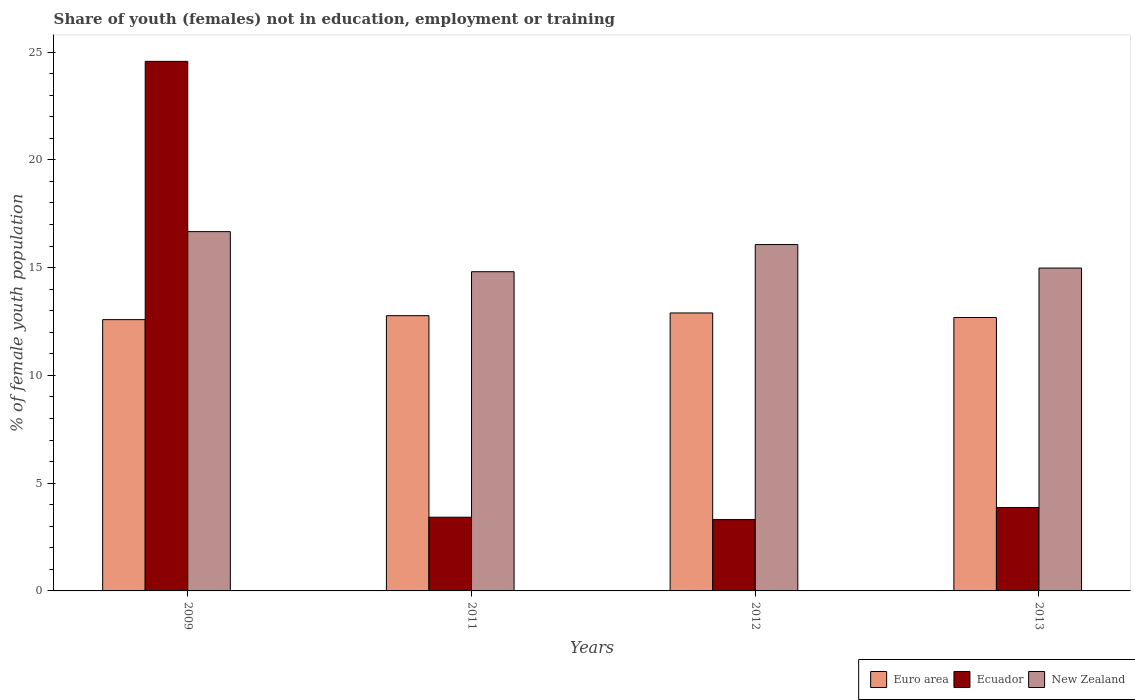How many different coloured bars are there?
Keep it short and to the point. 3. How many groups of bars are there?
Give a very brief answer. 4. Are the number of bars per tick equal to the number of legend labels?
Your response must be concise. Yes. Are the number of bars on each tick of the X-axis equal?
Your answer should be compact. Yes. How many bars are there on the 2nd tick from the left?
Offer a very short reply. 3. How many bars are there on the 3rd tick from the right?
Your answer should be very brief. 3. In how many cases, is the number of bars for a given year not equal to the number of legend labels?
Give a very brief answer. 0. What is the percentage of unemployed female population in in Ecuador in 2011?
Keep it short and to the point. 3.42. Across all years, what is the maximum percentage of unemployed female population in in Euro area?
Provide a succinct answer. 12.9. Across all years, what is the minimum percentage of unemployed female population in in Euro area?
Keep it short and to the point. 12.59. In which year was the percentage of unemployed female population in in Euro area maximum?
Make the answer very short. 2012. In which year was the percentage of unemployed female population in in New Zealand minimum?
Offer a very short reply. 2011. What is the total percentage of unemployed female population in in Euro area in the graph?
Your answer should be very brief. 50.94. What is the difference between the percentage of unemployed female population in in New Zealand in 2009 and that in 2013?
Your answer should be compact. 1.69. What is the difference between the percentage of unemployed female population in in Euro area in 2009 and the percentage of unemployed female population in in New Zealand in 2013?
Provide a short and direct response. -2.39. What is the average percentage of unemployed female population in in Ecuador per year?
Offer a very short reply. 8.79. In the year 2013, what is the difference between the percentage of unemployed female population in in New Zealand and percentage of unemployed female population in in Euro area?
Ensure brevity in your answer.  2.29. What is the ratio of the percentage of unemployed female population in in Euro area in 2009 to that in 2013?
Ensure brevity in your answer.  0.99. Is the difference between the percentage of unemployed female population in in New Zealand in 2009 and 2012 greater than the difference between the percentage of unemployed female population in in Euro area in 2009 and 2012?
Provide a short and direct response. Yes. What is the difference between the highest and the second highest percentage of unemployed female population in in New Zealand?
Keep it short and to the point. 0.6. What is the difference between the highest and the lowest percentage of unemployed female population in in Ecuador?
Keep it short and to the point. 21.26. What does the 2nd bar from the right in 2013 represents?
Provide a short and direct response. Ecuador. How many bars are there?
Offer a terse response. 12. How many years are there in the graph?
Make the answer very short. 4. Does the graph contain grids?
Ensure brevity in your answer.  No. Where does the legend appear in the graph?
Keep it short and to the point. Bottom right. How many legend labels are there?
Make the answer very short. 3. What is the title of the graph?
Ensure brevity in your answer.  Share of youth (females) not in education, employment or training. What is the label or title of the Y-axis?
Ensure brevity in your answer.  % of female youth population. What is the % of female youth population of Euro area in 2009?
Offer a terse response. 12.59. What is the % of female youth population in Ecuador in 2009?
Keep it short and to the point. 24.57. What is the % of female youth population in New Zealand in 2009?
Your answer should be compact. 16.67. What is the % of female youth population in Euro area in 2011?
Your response must be concise. 12.77. What is the % of female youth population of Ecuador in 2011?
Your answer should be very brief. 3.42. What is the % of female youth population in New Zealand in 2011?
Offer a terse response. 14.81. What is the % of female youth population of Euro area in 2012?
Keep it short and to the point. 12.9. What is the % of female youth population of Ecuador in 2012?
Keep it short and to the point. 3.31. What is the % of female youth population in New Zealand in 2012?
Provide a succinct answer. 16.07. What is the % of female youth population of Euro area in 2013?
Your response must be concise. 12.69. What is the % of female youth population in Ecuador in 2013?
Your response must be concise. 3.87. What is the % of female youth population of New Zealand in 2013?
Keep it short and to the point. 14.98. Across all years, what is the maximum % of female youth population of Euro area?
Provide a short and direct response. 12.9. Across all years, what is the maximum % of female youth population of Ecuador?
Offer a very short reply. 24.57. Across all years, what is the maximum % of female youth population of New Zealand?
Provide a short and direct response. 16.67. Across all years, what is the minimum % of female youth population in Euro area?
Offer a terse response. 12.59. Across all years, what is the minimum % of female youth population in Ecuador?
Provide a short and direct response. 3.31. Across all years, what is the minimum % of female youth population in New Zealand?
Ensure brevity in your answer.  14.81. What is the total % of female youth population in Euro area in the graph?
Your answer should be compact. 50.94. What is the total % of female youth population in Ecuador in the graph?
Give a very brief answer. 35.17. What is the total % of female youth population of New Zealand in the graph?
Offer a terse response. 62.53. What is the difference between the % of female youth population of Euro area in 2009 and that in 2011?
Provide a succinct answer. -0.18. What is the difference between the % of female youth population in Ecuador in 2009 and that in 2011?
Your answer should be compact. 21.15. What is the difference between the % of female youth population in New Zealand in 2009 and that in 2011?
Keep it short and to the point. 1.86. What is the difference between the % of female youth population of Euro area in 2009 and that in 2012?
Provide a succinct answer. -0.31. What is the difference between the % of female youth population in Ecuador in 2009 and that in 2012?
Offer a terse response. 21.26. What is the difference between the % of female youth population in New Zealand in 2009 and that in 2012?
Your response must be concise. 0.6. What is the difference between the % of female youth population in Euro area in 2009 and that in 2013?
Your answer should be very brief. -0.1. What is the difference between the % of female youth population of Ecuador in 2009 and that in 2013?
Offer a terse response. 20.7. What is the difference between the % of female youth population in New Zealand in 2009 and that in 2013?
Provide a succinct answer. 1.69. What is the difference between the % of female youth population of Euro area in 2011 and that in 2012?
Your answer should be very brief. -0.13. What is the difference between the % of female youth population of Ecuador in 2011 and that in 2012?
Provide a short and direct response. 0.11. What is the difference between the % of female youth population in New Zealand in 2011 and that in 2012?
Provide a succinct answer. -1.26. What is the difference between the % of female youth population in Euro area in 2011 and that in 2013?
Your response must be concise. 0.08. What is the difference between the % of female youth population in Ecuador in 2011 and that in 2013?
Ensure brevity in your answer.  -0.45. What is the difference between the % of female youth population of New Zealand in 2011 and that in 2013?
Provide a succinct answer. -0.17. What is the difference between the % of female youth population in Euro area in 2012 and that in 2013?
Provide a succinct answer. 0.21. What is the difference between the % of female youth population of Ecuador in 2012 and that in 2013?
Offer a terse response. -0.56. What is the difference between the % of female youth population of New Zealand in 2012 and that in 2013?
Keep it short and to the point. 1.09. What is the difference between the % of female youth population of Euro area in 2009 and the % of female youth population of Ecuador in 2011?
Ensure brevity in your answer.  9.17. What is the difference between the % of female youth population of Euro area in 2009 and the % of female youth population of New Zealand in 2011?
Keep it short and to the point. -2.22. What is the difference between the % of female youth population of Ecuador in 2009 and the % of female youth population of New Zealand in 2011?
Your answer should be very brief. 9.76. What is the difference between the % of female youth population of Euro area in 2009 and the % of female youth population of Ecuador in 2012?
Provide a succinct answer. 9.28. What is the difference between the % of female youth population of Euro area in 2009 and the % of female youth population of New Zealand in 2012?
Your response must be concise. -3.48. What is the difference between the % of female youth population in Euro area in 2009 and the % of female youth population in Ecuador in 2013?
Keep it short and to the point. 8.72. What is the difference between the % of female youth population in Euro area in 2009 and the % of female youth population in New Zealand in 2013?
Provide a short and direct response. -2.39. What is the difference between the % of female youth population in Ecuador in 2009 and the % of female youth population in New Zealand in 2013?
Make the answer very short. 9.59. What is the difference between the % of female youth population of Euro area in 2011 and the % of female youth population of Ecuador in 2012?
Offer a terse response. 9.46. What is the difference between the % of female youth population in Euro area in 2011 and the % of female youth population in New Zealand in 2012?
Offer a terse response. -3.3. What is the difference between the % of female youth population of Ecuador in 2011 and the % of female youth population of New Zealand in 2012?
Offer a very short reply. -12.65. What is the difference between the % of female youth population of Euro area in 2011 and the % of female youth population of Ecuador in 2013?
Your answer should be compact. 8.9. What is the difference between the % of female youth population in Euro area in 2011 and the % of female youth population in New Zealand in 2013?
Provide a short and direct response. -2.21. What is the difference between the % of female youth population in Ecuador in 2011 and the % of female youth population in New Zealand in 2013?
Offer a terse response. -11.56. What is the difference between the % of female youth population of Euro area in 2012 and the % of female youth population of Ecuador in 2013?
Offer a terse response. 9.03. What is the difference between the % of female youth population of Euro area in 2012 and the % of female youth population of New Zealand in 2013?
Your answer should be compact. -2.08. What is the difference between the % of female youth population of Ecuador in 2012 and the % of female youth population of New Zealand in 2013?
Your response must be concise. -11.67. What is the average % of female youth population of Euro area per year?
Ensure brevity in your answer.  12.73. What is the average % of female youth population of Ecuador per year?
Provide a succinct answer. 8.79. What is the average % of female youth population in New Zealand per year?
Offer a very short reply. 15.63. In the year 2009, what is the difference between the % of female youth population in Euro area and % of female youth population in Ecuador?
Offer a very short reply. -11.98. In the year 2009, what is the difference between the % of female youth population in Euro area and % of female youth population in New Zealand?
Ensure brevity in your answer.  -4.08. In the year 2011, what is the difference between the % of female youth population of Euro area and % of female youth population of Ecuador?
Your answer should be very brief. 9.35. In the year 2011, what is the difference between the % of female youth population of Euro area and % of female youth population of New Zealand?
Your answer should be compact. -2.04. In the year 2011, what is the difference between the % of female youth population of Ecuador and % of female youth population of New Zealand?
Your answer should be very brief. -11.39. In the year 2012, what is the difference between the % of female youth population of Euro area and % of female youth population of Ecuador?
Give a very brief answer. 9.59. In the year 2012, what is the difference between the % of female youth population in Euro area and % of female youth population in New Zealand?
Give a very brief answer. -3.17. In the year 2012, what is the difference between the % of female youth population of Ecuador and % of female youth population of New Zealand?
Give a very brief answer. -12.76. In the year 2013, what is the difference between the % of female youth population in Euro area and % of female youth population in Ecuador?
Ensure brevity in your answer.  8.82. In the year 2013, what is the difference between the % of female youth population of Euro area and % of female youth population of New Zealand?
Offer a terse response. -2.29. In the year 2013, what is the difference between the % of female youth population in Ecuador and % of female youth population in New Zealand?
Give a very brief answer. -11.11. What is the ratio of the % of female youth population in Euro area in 2009 to that in 2011?
Ensure brevity in your answer.  0.99. What is the ratio of the % of female youth population in Ecuador in 2009 to that in 2011?
Your response must be concise. 7.18. What is the ratio of the % of female youth population in New Zealand in 2009 to that in 2011?
Provide a short and direct response. 1.13. What is the ratio of the % of female youth population of Ecuador in 2009 to that in 2012?
Offer a terse response. 7.42. What is the ratio of the % of female youth population in New Zealand in 2009 to that in 2012?
Provide a succinct answer. 1.04. What is the ratio of the % of female youth population in Ecuador in 2009 to that in 2013?
Give a very brief answer. 6.35. What is the ratio of the % of female youth population of New Zealand in 2009 to that in 2013?
Provide a short and direct response. 1.11. What is the ratio of the % of female youth population in Euro area in 2011 to that in 2012?
Provide a short and direct response. 0.99. What is the ratio of the % of female youth population in Ecuador in 2011 to that in 2012?
Offer a terse response. 1.03. What is the ratio of the % of female youth population of New Zealand in 2011 to that in 2012?
Keep it short and to the point. 0.92. What is the ratio of the % of female youth population of Euro area in 2011 to that in 2013?
Ensure brevity in your answer.  1.01. What is the ratio of the % of female youth population in Ecuador in 2011 to that in 2013?
Your answer should be very brief. 0.88. What is the ratio of the % of female youth population of New Zealand in 2011 to that in 2013?
Keep it short and to the point. 0.99. What is the ratio of the % of female youth population in Euro area in 2012 to that in 2013?
Offer a terse response. 1.02. What is the ratio of the % of female youth population of Ecuador in 2012 to that in 2013?
Ensure brevity in your answer.  0.86. What is the ratio of the % of female youth population in New Zealand in 2012 to that in 2013?
Provide a short and direct response. 1.07. What is the difference between the highest and the second highest % of female youth population of Euro area?
Offer a very short reply. 0.13. What is the difference between the highest and the second highest % of female youth population of Ecuador?
Your answer should be compact. 20.7. What is the difference between the highest and the second highest % of female youth population of New Zealand?
Keep it short and to the point. 0.6. What is the difference between the highest and the lowest % of female youth population of Euro area?
Keep it short and to the point. 0.31. What is the difference between the highest and the lowest % of female youth population in Ecuador?
Give a very brief answer. 21.26. What is the difference between the highest and the lowest % of female youth population in New Zealand?
Offer a very short reply. 1.86. 